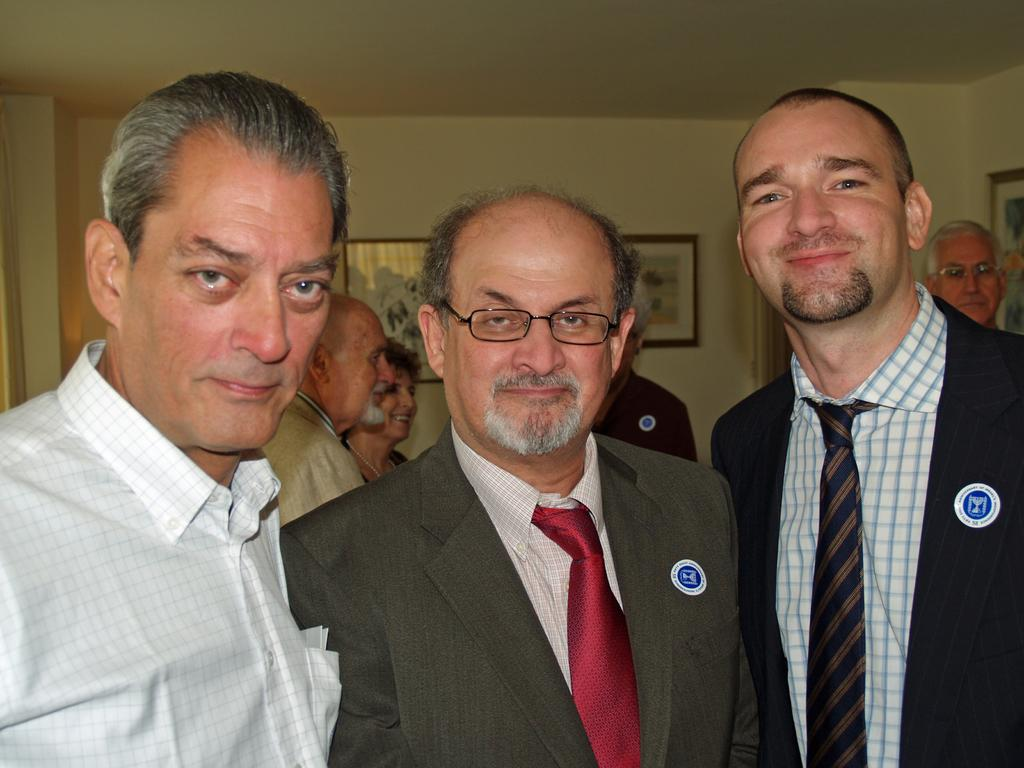Who or what is present in the image? There are people in the image. What are some of the people wearing? Some people are wearing coats and badges. What can be seen in the background of the image? There are frames on the wall in the background of the image. What type of thread is being used to hang the frames on the wall in the image? There is no information about the type of thread used to hang the frames in the image. 